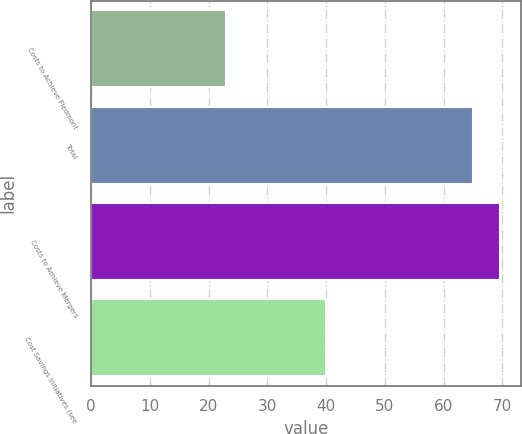Convert chart. <chart><loc_0><loc_0><loc_500><loc_500><bar_chart><fcel>Costs to Achieve Piedmont<fcel>Total<fcel>Costs to Achieve Mergers<fcel>Cost Savings Initiatives (see<nl><fcel>23<fcel>65<fcel>69.6<fcel>40<nl></chart> 